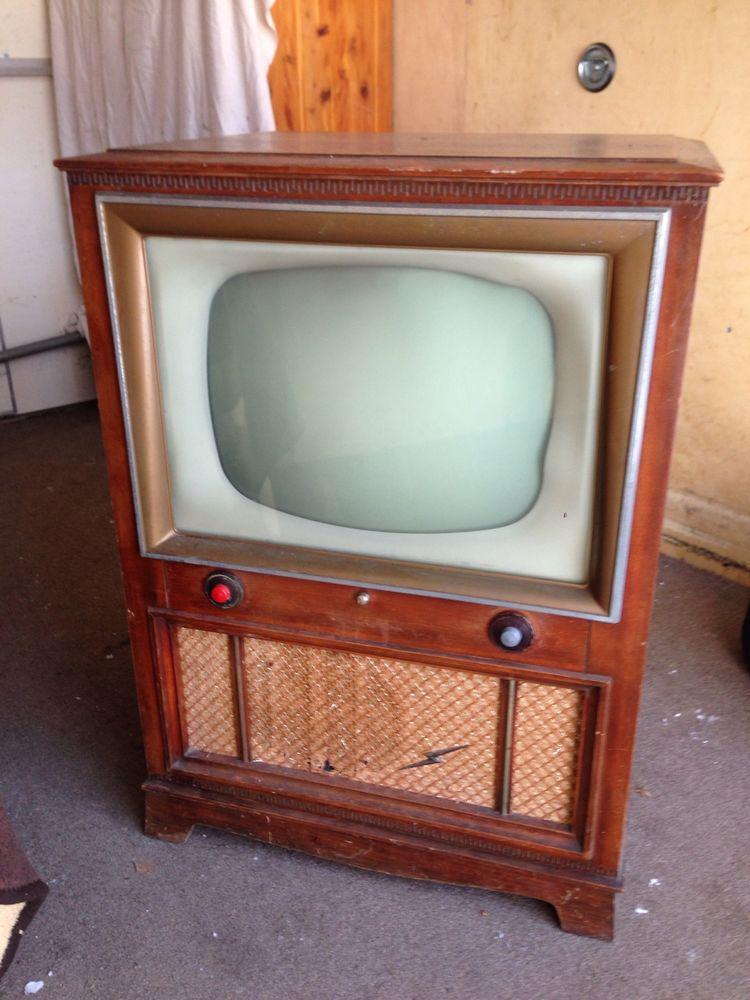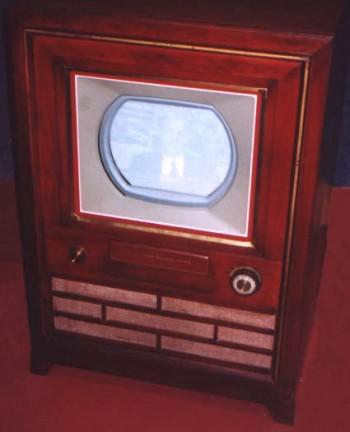The first image is the image on the left, the second image is the image on the right. Analyze the images presented: Is the assertion "In at lease on image, there is a oval shaped tv screen held by wooden tv case that has three rows of brick like rectangles." valid? Answer yes or no. Yes. The first image is the image on the left, the second image is the image on the right. For the images displayed, is the sentence "The speaker under one of the television monitors shows a horizontal brick-like pattern." factually correct? Answer yes or no. Yes. 